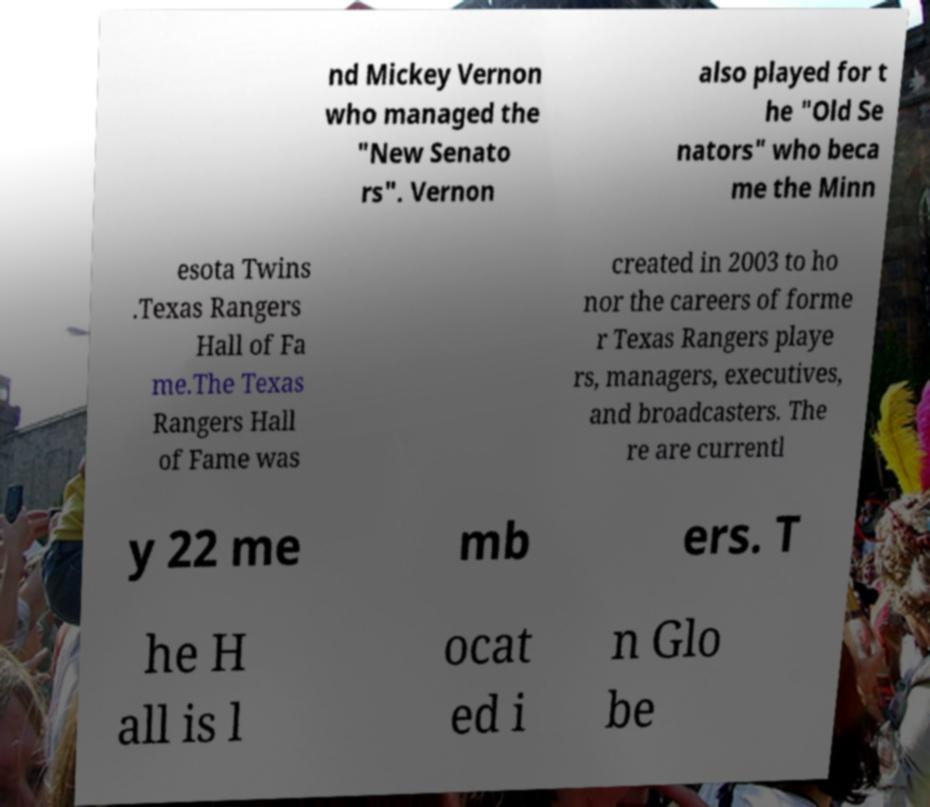There's text embedded in this image that I need extracted. Can you transcribe it verbatim? nd Mickey Vernon who managed the "New Senato rs". Vernon also played for t he "Old Se nators" who beca me the Minn esota Twins .Texas Rangers Hall of Fa me.The Texas Rangers Hall of Fame was created in 2003 to ho nor the careers of forme r Texas Rangers playe rs, managers, executives, and broadcasters. The re are currentl y 22 me mb ers. T he H all is l ocat ed i n Glo be 